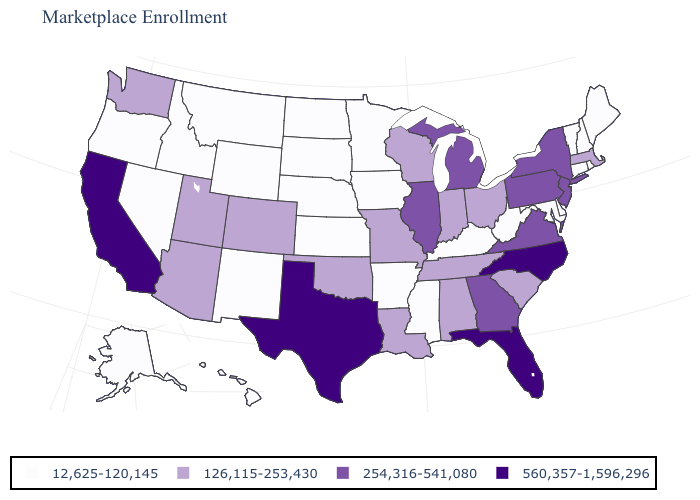Name the states that have a value in the range 12,625-120,145?
Write a very short answer. Alaska, Arkansas, Connecticut, Delaware, Hawaii, Idaho, Iowa, Kansas, Kentucky, Maine, Maryland, Minnesota, Mississippi, Montana, Nebraska, Nevada, New Hampshire, New Mexico, North Dakota, Oregon, Rhode Island, South Dakota, Vermont, West Virginia, Wyoming. What is the value of Missouri?
Be succinct. 126,115-253,430. What is the value of Wyoming?
Answer briefly. 12,625-120,145. What is the value of Illinois?
Be succinct. 254,316-541,080. Does the first symbol in the legend represent the smallest category?
Answer briefly. Yes. What is the value of Illinois?
Quick response, please. 254,316-541,080. What is the value of Pennsylvania?
Concise answer only. 254,316-541,080. Name the states that have a value in the range 560,357-1,596,296?
Short answer required. California, Florida, North Carolina, Texas. What is the value of Hawaii?
Be succinct. 12,625-120,145. Does Delaware have a lower value than Oregon?
Give a very brief answer. No. Does Michigan have a higher value than Florida?
Short answer required. No. Does Wyoming have the same value as South Dakota?
Keep it brief. Yes. Name the states that have a value in the range 560,357-1,596,296?
Keep it brief. California, Florida, North Carolina, Texas. What is the lowest value in the Northeast?
Short answer required. 12,625-120,145. 